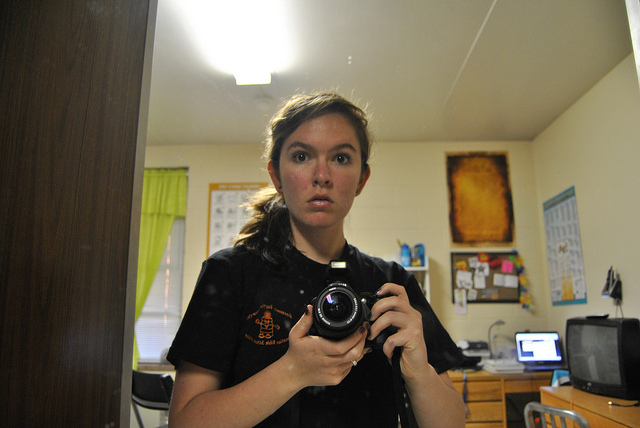Identify the text contained in this image. S 